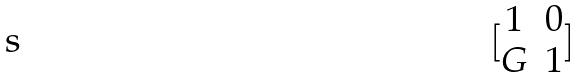<formula> <loc_0><loc_0><loc_500><loc_500>[ \begin{matrix} 1 & 0 \\ G & 1 \end{matrix} ]</formula> 